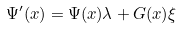<formula> <loc_0><loc_0><loc_500><loc_500>\Psi ^ { \prime } ( x ) = \Psi ( x ) \lambda + G ( x ) \xi</formula> 